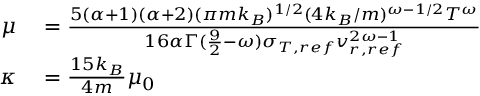<formula> <loc_0><loc_0><loc_500><loc_500>\begin{array} { r l } { \mu } & = \frac { 5 ( \alpha + 1 ) ( \alpha + 2 ) ( \pi m k _ { B } ) ^ { 1 / 2 } ( 4 k _ { B } / m ) ^ { \omega - 1 / 2 } T ^ { \omega } } { 1 6 \alpha \Gamma ( \frac { 9 } { 2 } - \omega ) \sigma _ { T , r e f } v _ { r , r e f } ^ { 2 \omega - 1 } } } \\ { \kappa } & = \frac { 1 5 k _ { B } } { 4 m } \mu _ { 0 } } \end{array}</formula> 